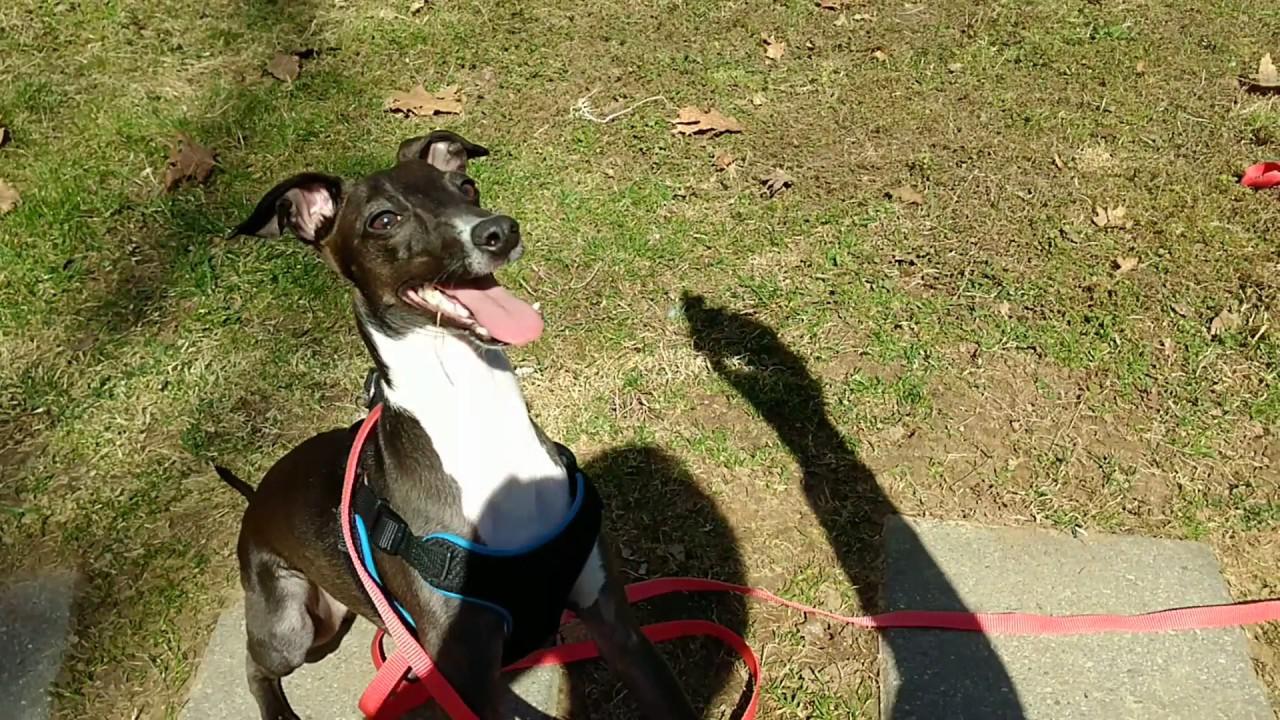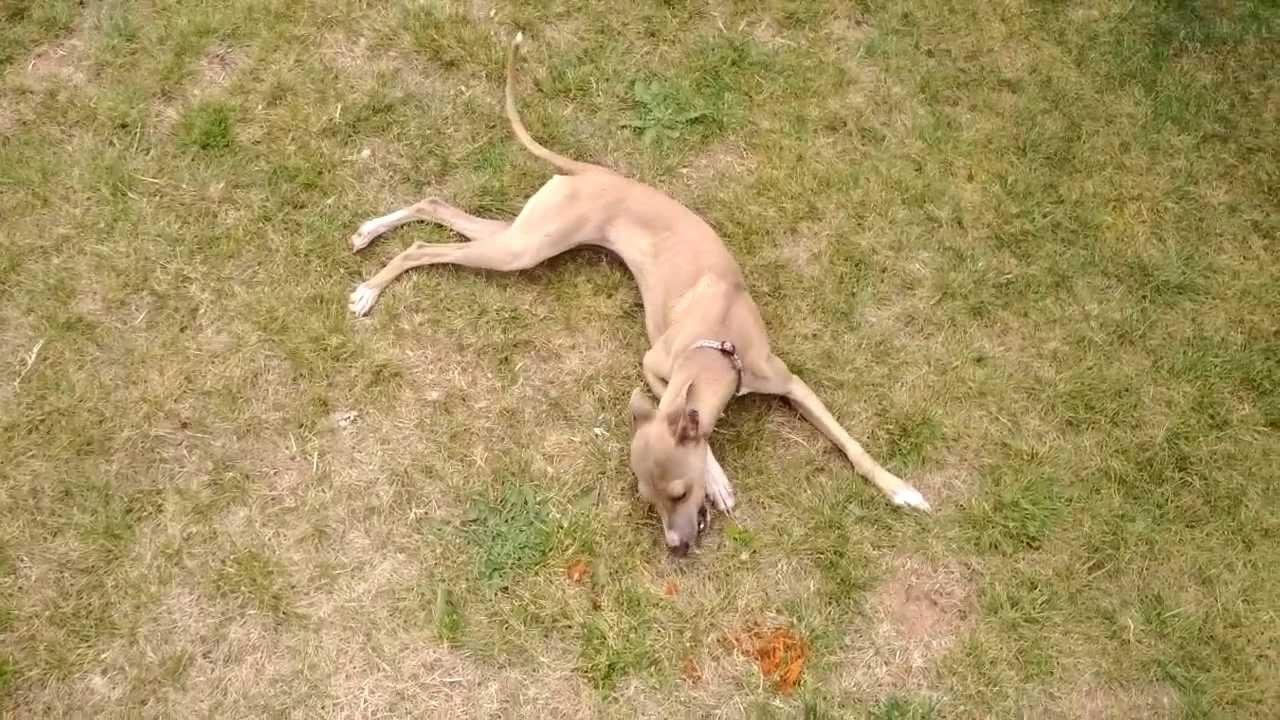The first image is the image on the left, the second image is the image on the right. Analyze the images presented: Is the assertion "One of the two dogs in the left image has its mouth open, displaying its teeth and a bit of tongue." valid? Answer yes or no. No. The first image is the image on the left, the second image is the image on the right. For the images displayed, is the sentence "Two dogs, one with an open mouth, are near one another on a sandy beach in one image." factually correct? Answer yes or no. No. 